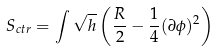<formula> <loc_0><loc_0><loc_500><loc_500>S _ { c t r } = \int \sqrt { h } \left ( \frac { R } { 2 } - \frac { 1 } { 4 } ( \partial \phi ) ^ { 2 } \right )</formula> 